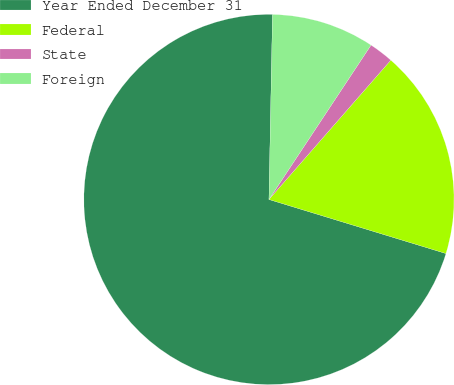<chart> <loc_0><loc_0><loc_500><loc_500><pie_chart><fcel>Year Ended December 31<fcel>Federal<fcel>State<fcel>Foreign<nl><fcel>70.59%<fcel>18.28%<fcel>2.14%<fcel>8.99%<nl></chart> 